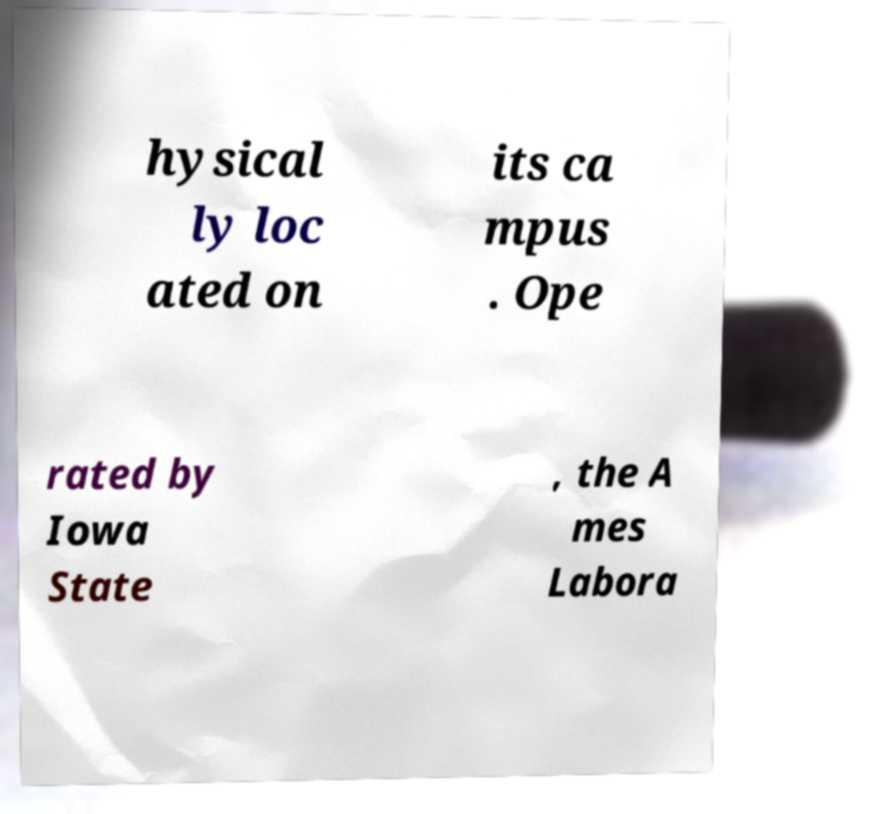Please read and relay the text visible in this image. What does it say? hysical ly loc ated on its ca mpus . Ope rated by Iowa State , the A mes Labora 